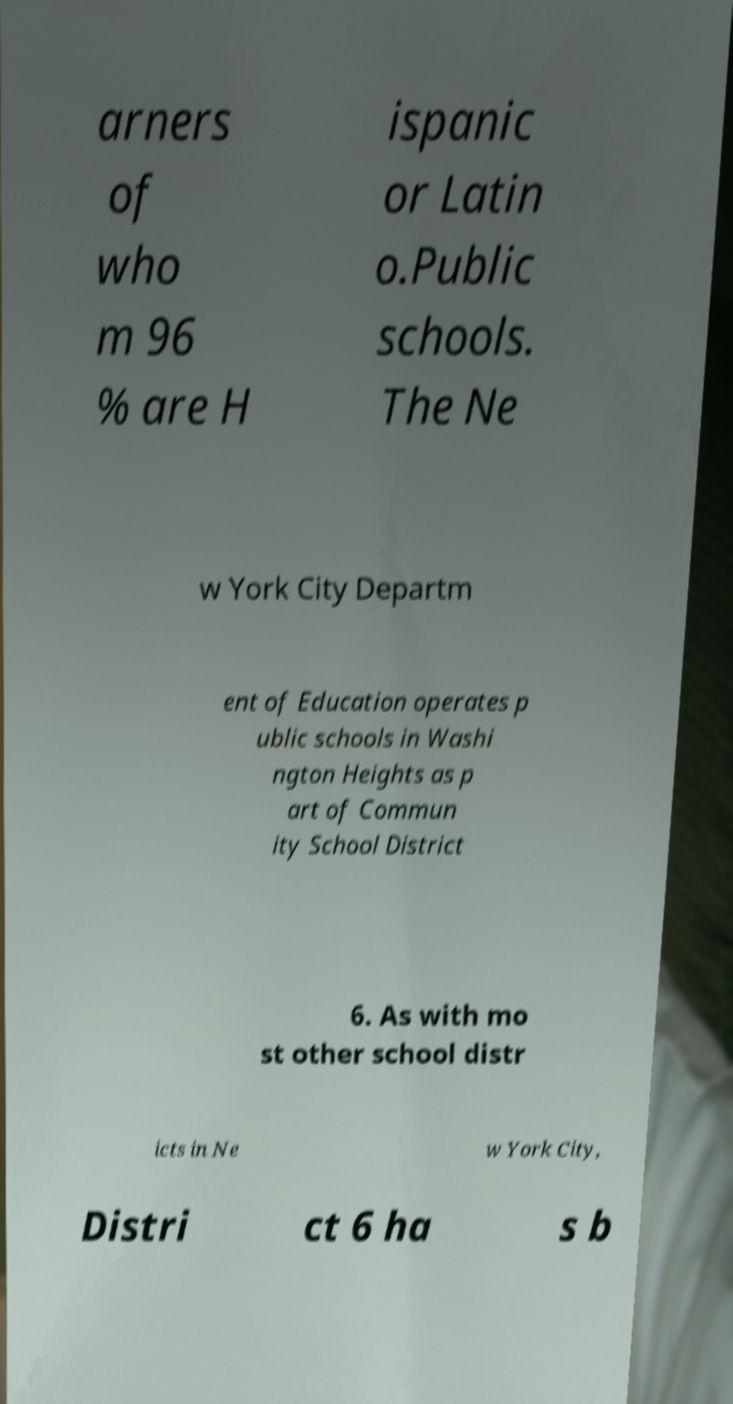There's text embedded in this image that I need extracted. Can you transcribe it verbatim? arners of who m 96 % are H ispanic or Latin o.Public schools. The Ne w York City Departm ent of Education operates p ublic schools in Washi ngton Heights as p art of Commun ity School District 6. As with mo st other school distr icts in Ne w York City, Distri ct 6 ha s b 